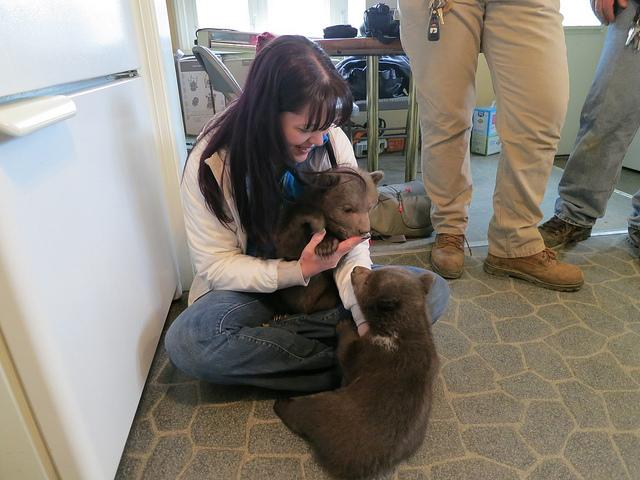What is she sitting next to on the left?

Choices:
A) microwave
B) stove
C) dishwasher
D) fridge fridge 